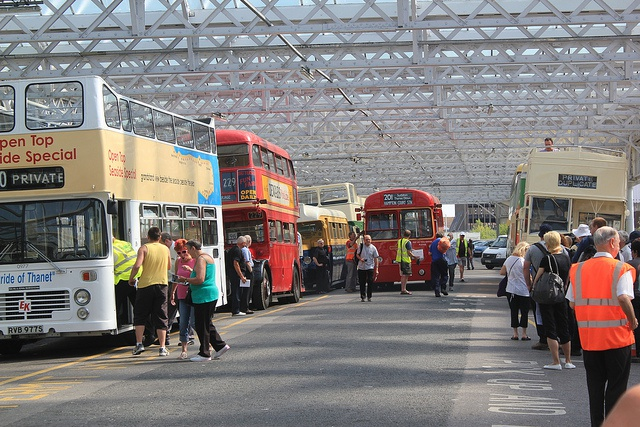Describe the objects in this image and their specific colors. I can see bus in darkgreen, darkgray, black, gray, and tan tones, bus in darkgreen, black, gray, salmon, and maroon tones, bus in darkgreen, darkgray, gray, and black tones, people in darkgreen, black, red, and gray tones, and people in darkgreen, black, gray, darkgray, and lightgray tones in this image. 